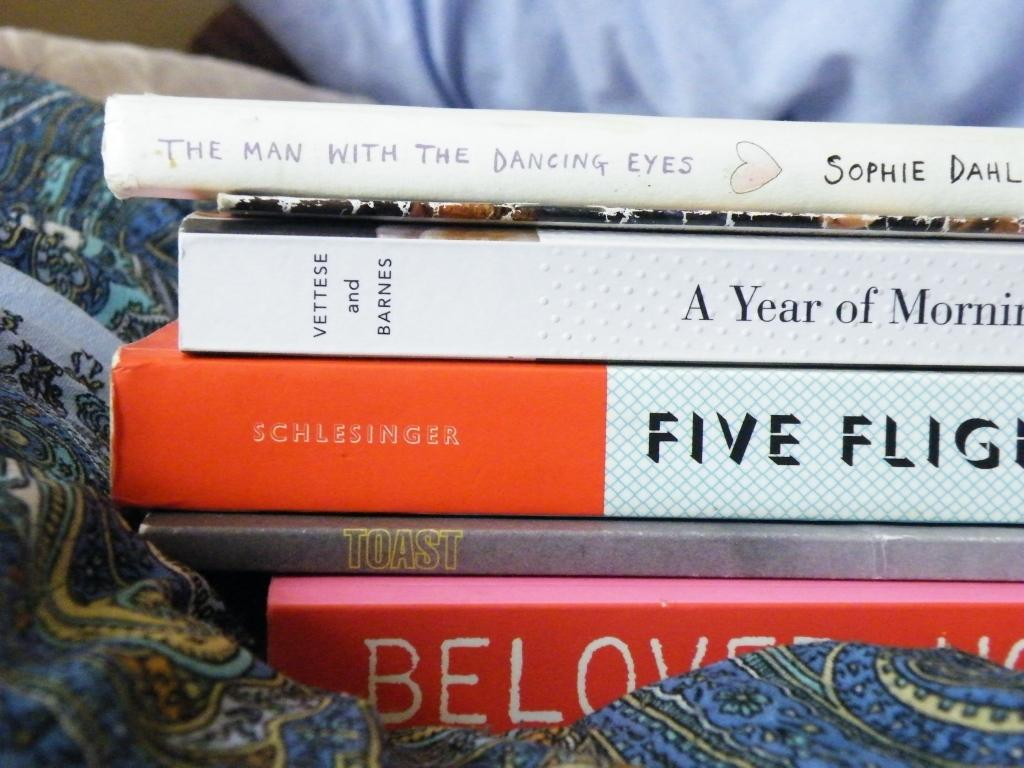<image>
Render a clear and concise summary of the photo. A book by Schlesinger is in a stack of books. 